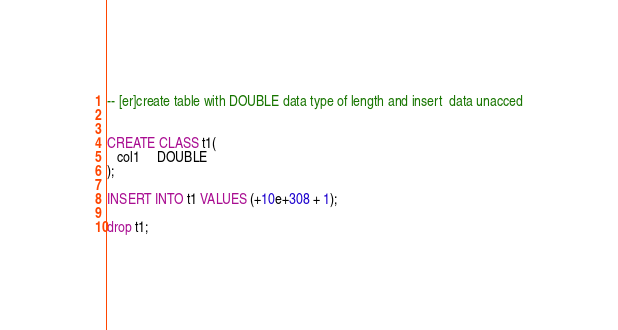<code> <loc_0><loc_0><loc_500><loc_500><_SQL_>-- [er]create table with DOUBLE data type of length and insert  data unacced


CREATE CLASS t1(
   col1     DOUBLE 
);

INSERT INTO t1 VALUES (+10e+308 + 1);

drop t1;</code> 